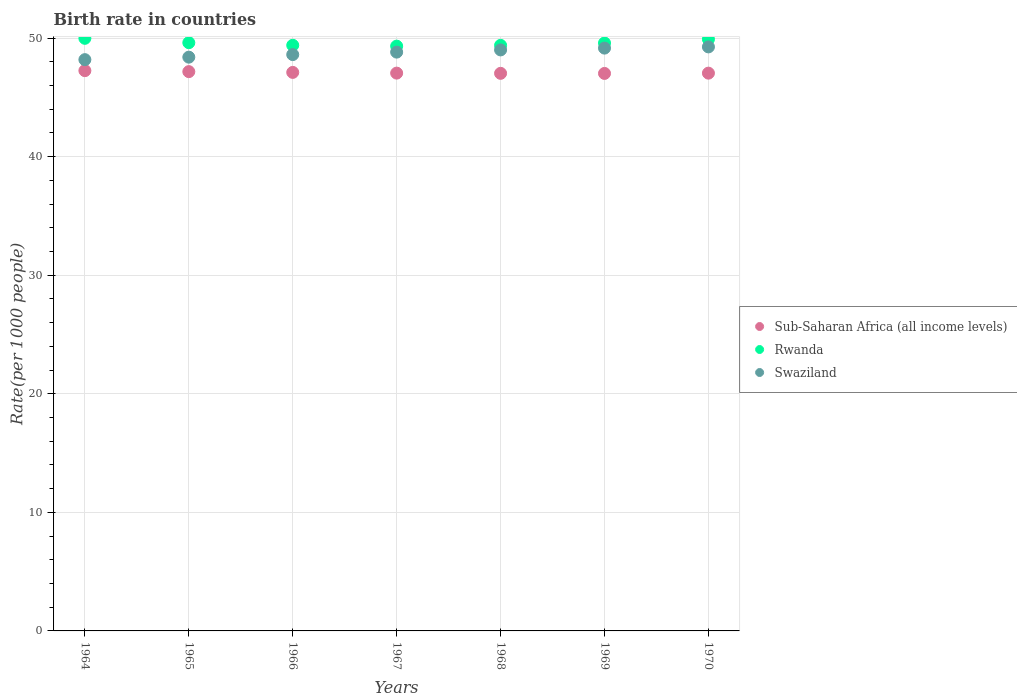Is the number of dotlines equal to the number of legend labels?
Your answer should be compact. Yes. What is the birth rate in Swaziland in 1966?
Offer a very short reply. 48.61. Across all years, what is the maximum birth rate in Sub-Saharan Africa (all income levels)?
Offer a very short reply. 47.26. Across all years, what is the minimum birth rate in Sub-Saharan Africa (all income levels)?
Provide a short and direct response. 47.02. In which year was the birth rate in Sub-Saharan Africa (all income levels) maximum?
Make the answer very short. 1964. In which year was the birth rate in Rwanda minimum?
Ensure brevity in your answer.  1967. What is the total birth rate in Sub-Saharan Africa (all income levels) in the graph?
Your answer should be compact. 329.7. What is the difference between the birth rate in Rwanda in 1968 and that in 1969?
Give a very brief answer. -0.2. What is the difference between the birth rate in Swaziland in 1964 and the birth rate in Rwanda in 1965?
Make the answer very short. -1.43. What is the average birth rate in Sub-Saharan Africa (all income levels) per year?
Your response must be concise. 47.1. In the year 1969, what is the difference between the birth rate in Rwanda and birth rate in Swaziland?
Offer a terse response. 0.43. What is the ratio of the birth rate in Rwanda in 1964 to that in 1967?
Make the answer very short. 1.01. What is the difference between the highest and the second highest birth rate in Sub-Saharan Africa (all income levels)?
Keep it short and to the point. 0.08. What is the difference between the highest and the lowest birth rate in Sub-Saharan Africa (all income levels)?
Give a very brief answer. 0.24. In how many years, is the birth rate in Sub-Saharan Africa (all income levels) greater than the average birth rate in Sub-Saharan Africa (all income levels) taken over all years?
Offer a terse response. 3. Is the sum of the birth rate in Sub-Saharan Africa (all income levels) in 1964 and 1965 greater than the maximum birth rate in Rwanda across all years?
Offer a very short reply. Yes. Does the birth rate in Sub-Saharan Africa (all income levels) monotonically increase over the years?
Ensure brevity in your answer.  No. Is the birth rate in Swaziland strictly less than the birth rate in Rwanda over the years?
Keep it short and to the point. Yes. How many dotlines are there?
Offer a very short reply. 3. What is the difference between two consecutive major ticks on the Y-axis?
Your response must be concise. 10. Does the graph contain any zero values?
Provide a succinct answer. No. Does the graph contain grids?
Keep it short and to the point. Yes. How many legend labels are there?
Offer a very short reply. 3. How are the legend labels stacked?
Provide a short and direct response. Vertical. What is the title of the graph?
Make the answer very short. Birth rate in countries. What is the label or title of the Y-axis?
Offer a very short reply. Rate(per 1000 people). What is the Rate(per 1000 people) in Sub-Saharan Africa (all income levels) in 1964?
Offer a terse response. 47.26. What is the Rate(per 1000 people) in Rwanda in 1964?
Your answer should be compact. 49.98. What is the Rate(per 1000 people) in Swaziland in 1964?
Give a very brief answer. 48.19. What is the Rate(per 1000 people) of Sub-Saharan Africa (all income levels) in 1965?
Provide a succinct answer. 47.18. What is the Rate(per 1000 people) of Rwanda in 1965?
Give a very brief answer. 49.62. What is the Rate(per 1000 people) in Swaziland in 1965?
Give a very brief answer. 48.4. What is the Rate(per 1000 people) in Sub-Saharan Africa (all income levels) in 1966?
Provide a short and direct response. 47.11. What is the Rate(per 1000 people) of Rwanda in 1966?
Give a very brief answer. 49.4. What is the Rate(per 1000 people) of Swaziland in 1966?
Your response must be concise. 48.61. What is the Rate(per 1000 people) in Sub-Saharan Africa (all income levels) in 1967?
Your answer should be compact. 47.05. What is the Rate(per 1000 people) in Rwanda in 1967?
Provide a short and direct response. 49.33. What is the Rate(per 1000 people) in Swaziland in 1967?
Your answer should be very brief. 48.82. What is the Rate(per 1000 people) in Sub-Saharan Africa (all income levels) in 1968?
Offer a terse response. 47.03. What is the Rate(per 1000 people) in Rwanda in 1968?
Your answer should be compact. 49.39. What is the Rate(per 1000 people) in Swaziland in 1968?
Provide a succinct answer. 49.01. What is the Rate(per 1000 people) of Sub-Saharan Africa (all income levels) in 1969?
Give a very brief answer. 47.02. What is the Rate(per 1000 people) in Rwanda in 1969?
Make the answer very short. 49.59. What is the Rate(per 1000 people) in Swaziland in 1969?
Provide a short and direct response. 49.16. What is the Rate(per 1000 people) of Sub-Saharan Africa (all income levels) in 1970?
Your answer should be compact. 47.05. What is the Rate(per 1000 people) of Rwanda in 1970?
Ensure brevity in your answer.  49.91. What is the Rate(per 1000 people) in Swaziland in 1970?
Provide a short and direct response. 49.26. Across all years, what is the maximum Rate(per 1000 people) in Sub-Saharan Africa (all income levels)?
Your response must be concise. 47.26. Across all years, what is the maximum Rate(per 1000 people) in Rwanda?
Offer a very short reply. 49.98. Across all years, what is the maximum Rate(per 1000 people) in Swaziland?
Make the answer very short. 49.26. Across all years, what is the minimum Rate(per 1000 people) of Sub-Saharan Africa (all income levels)?
Make the answer very short. 47.02. Across all years, what is the minimum Rate(per 1000 people) in Rwanda?
Give a very brief answer. 49.33. Across all years, what is the minimum Rate(per 1000 people) of Swaziland?
Offer a very short reply. 48.19. What is the total Rate(per 1000 people) of Sub-Saharan Africa (all income levels) in the graph?
Provide a succinct answer. 329.7. What is the total Rate(per 1000 people) in Rwanda in the graph?
Your answer should be very brief. 347.22. What is the total Rate(per 1000 people) in Swaziland in the graph?
Make the answer very short. 341.45. What is the difference between the Rate(per 1000 people) in Sub-Saharan Africa (all income levels) in 1964 and that in 1965?
Offer a very short reply. 0.08. What is the difference between the Rate(per 1000 people) of Rwanda in 1964 and that in 1965?
Provide a short and direct response. 0.37. What is the difference between the Rate(per 1000 people) in Swaziland in 1964 and that in 1965?
Your answer should be compact. -0.21. What is the difference between the Rate(per 1000 people) of Sub-Saharan Africa (all income levels) in 1964 and that in 1966?
Your answer should be compact. 0.15. What is the difference between the Rate(per 1000 people) in Rwanda in 1964 and that in 1966?
Offer a terse response. 0.59. What is the difference between the Rate(per 1000 people) in Swaziland in 1964 and that in 1966?
Offer a very short reply. -0.43. What is the difference between the Rate(per 1000 people) in Sub-Saharan Africa (all income levels) in 1964 and that in 1967?
Offer a terse response. 0.21. What is the difference between the Rate(per 1000 people) of Rwanda in 1964 and that in 1967?
Your answer should be very brief. 0.66. What is the difference between the Rate(per 1000 people) of Swaziland in 1964 and that in 1967?
Provide a succinct answer. -0.64. What is the difference between the Rate(per 1000 people) of Sub-Saharan Africa (all income levels) in 1964 and that in 1968?
Offer a very short reply. 0.23. What is the difference between the Rate(per 1000 people) in Rwanda in 1964 and that in 1968?
Your response must be concise. 0.59. What is the difference between the Rate(per 1000 people) of Swaziland in 1964 and that in 1968?
Your answer should be compact. -0.82. What is the difference between the Rate(per 1000 people) in Sub-Saharan Africa (all income levels) in 1964 and that in 1969?
Provide a short and direct response. 0.24. What is the difference between the Rate(per 1000 people) in Rwanda in 1964 and that in 1969?
Your answer should be very brief. 0.4. What is the difference between the Rate(per 1000 people) of Swaziland in 1964 and that in 1969?
Provide a succinct answer. -0.97. What is the difference between the Rate(per 1000 people) in Sub-Saharan Africa (all income levels) in 1964 and that in 1970?
Offer a very short reply. 0.21. What is the difference between the Rate(per 1000 people) in Rwanda in 1964 and that in 1970?
Offer a terse response. 0.07. What is the difference between the Rate(per 1000 people) of Swaziland in 1964 and that in 1970?
Your response must be concise. -1.07. What is the difference between the Rate(per 1000 people) of Sub-Saharan Africa (all income levels) in 1965 and that in 1966?
Your answer should be very brief. 0.07. What is the difference between the Rate(per 1000 people) in Rwanda in 1965 and that in 1966?
Offer a very short reply. 0.22. What is the difference between the Rate(per 1000 people) in Swaziland in 1965 and that in 1966?
Give a very brief answer. -0.22. What is the difference between the Rate(per 1000 people) in Sub-Saharan Africa (all income levels) in 1965 and that in 1967?
Provide a short and direct response. 0.13. What is the difference between the Rate(per 1000 people) of Rwanda in 1965 and that in 1967?
Provide a succinct answer. 0.29. What is the difference between the Rate(per 1000 people) in Swaziland in 1965 and that in 1967?
Offer a very short reply. -0.42. What is the difference between the Rate(per 1000 people) in Sub-Saharan Africa (all income levels) in 1965 and that in 1968?
Provide a succinct answer. 0.14. What is the difference between the Rate(per 1000 people) in Rwanda in 1965 and that in 1968?
Make the answer very short. 0.22. What is the difference between the Rate(per 1000 people) of Swaziland in 1965 and that in 1968?
Your answer should be compact. -0.61. What is the difference between the Rate(per 1000 people) in Sub-Saharan Africa (all income levels) in 1965 and that in 1969?
Provide a short and direct response. 0.15. What is the difference between the Rate(per 1000 people) of Rwanda in 1965 and that in 1969?
Provide a succinct answer. 0.03. What is the difference between the Rate(per 1000 people) in Swaziland in 1965 and that in 1969?
Ensure brevity in your answer.  -0.76. What is the difference between the Rate(per 1000 people) of Sub-Saharan Africa (all income levels) in 1965 and that in 1970?
Give a very brief answer. 0.13. What is the difference between the Rate(per 1000 people) in Rwanda in 1965 and that in 1970?
Your answer should be compact. -0.29. What is the difference between the Rate(per 1000 people) of Swaziland in 1965 and that in 1970?
Make the answer very short. -0.86. What is the difference between the Rate(per 1000 people) in Sub-Saharan Africa (all income levels) in 1966 and that in 1967?
Ensure brevity in your answer.  0.06. What is the difference between the Rate(per 1000 people) in Rwanda in 1966 and that in 1967?
Make the answer very short. 0.07. What is the difference between the Rate(per 1000 people) in Swaziland in 1966 and that in 1967?
Your response must be concise. -0.21. What is the difference between the Rate(per 1000 people) in Sub-Saharan Africa (all income levels) in 1966 and that in 1968?
Your response must be concise. 0.08. What is the difference between the Rate(per 1000 people) in Rwanda in 1966 and that in 1968?
Offer a very short reply. 0.01. What is the difference between the Rate(per 1000 people) in Swaziland in 1966 and that in 1968?
Provide a short and direct response. -0.4. What is the difference between the Rate(per 1000 people) of Sub-Saharan Africa (all income levels) in 1966 and that in 1969?
Keep it short and to the point. 0.09. What is the difference between the Rate(per 1000 people) in Rwanda in 1966 and that in 1969?
Offer a terse response. -0.19. What is the difference between the Rate(per 1000 people) of Swaziland in 1966 and that in 1969?
Provide a succinct answer. -0.55. What is the difference between the Rate(per 1000 people) of Sub-Saharan Africa (all income levels) in 1966 and that in 1970?
Offer a very short reply. 0.06. What is the difference between the Rate(per 1000 people) in Rwanda in 1966 and that in 1970?
Your answer should be compact. -0.51. What is the difference between the Rate(per 1000 people) in Swaziland in 1966 and that in 1970?
Keep it short and to the point. -0.65. What is the difference between the Rate(per 1000 people) of Sub-Saharan Africa (all income levels) in 1967 and that in 1968?
Your answer should be compact. 0.02. What is the difference between the Rate(per 1000 people) in Rwanda in 1967 and that in 1968?
Make the answer very short. -0.07. What is the difference between the Rate(per 1000 people) in Swaziland in 1967 and that in 1968?
Your answer should be very brief. -0.19. What is the difference between the Rate(per 1000 people) of Sub-Saharan Africa (all income levels) in 1967 and that in 1969?
Give a very brief answer. 0.03. What is the difference between the Rate(per 1000 people) in Rwanda in 1967 and that in 1969?
Keep it short and to the point. -0.26. What is the difference between the Rate(per 1000 people) of Swaziland in 1967 and that in 1969?
Your answer should be compact. -0.34. What is the difference between the Rate(per 1000 people) in Sub-Saharan Africa (all income levels) in 1967 and that in 1970?
Your response must be concise. 0. What is the difference between the Rate(per 1000 people) in Rwanda in 1967 and that in 1970?
Your answer should be very brief. -0.58. What is the difference between the Rate(per 1000 people) of Swaziland in 1967 and that in 1970?
Your answer should be compact. -0.44. What is the difference between the Rate(per 1000 people) of Sub-Saharan Africa (all income levels) in 1968 and that in 1969?
Offer a terse response. 0.01. What is the difference between the Rate(per 1000 people) of Rwanda in 1968 and that in 1969?
Your answer should be compact. -0.2. What is the difference between the Rate(per 1000 people) of Swaziland in 1968 and that in 1969?
Your answer should be compact. -0.15. What is the difference between the Rate(per 1000 people) of Sub-Saharan Africa (all income levels) in 1968 and that in 1970?
Your answer should be compact. -0.02. What is the difference between the Rate(per 1000 people) of Rwanda in 1968 and that in 1970?
Offer a terse response. -0.52. What is the difference between the Rate(per 1000 people) in Swaziland in 1968 and that in 1970?
Give a very brief answer. -0.25. What is the difference between the Rate(per 1000 people) in Sub-Saharan Africa (all income levels) in 1969 and that in 1970?
Provide a short and direct response. -0.02. What is the difference between the Rate(per 1000 people) in Rwanda in 1969 and that in 1970?
Provide a short and direct response. -0.32. What is the difference between the Rate(per 1000 people) in Swaziland in 1969 and that in 1970?
Provide a succinct answer. -0.1. What is the difference between the Rate(per 1000 people) of Sub-Saharan Africa (all income levels) in 1964 and the Rate(per 1000 people) of Rwanda in 1965?
Your answer should be very brief. -2.36. What is the difference between the Rate(per 1000 people) of Sub-Saharan Africa (all income levels) in 1964 and the Rate(per 1000 people) of Swaziland in 1965?
Offer a terse response. -1.14. What is the difference between the Rate(per 1000 people) in Rwanda in 1964 and the Rate(per 1000 people) in Swaziland in 1965?
Give a very brief answer. 1.59. What is the difference between the Rate(per 1000 people) of Sub-Saharan Africa (all income levels) in 1964 and the Rate(per 1000 people) of Rwanda in 1966?
Your response must be concise. -2.14. What is the difference between the Rate(per 1000 people) of Sub-Saharan Africa (all income levels) in 1964 and the Rate(per 1000 people) of Swaziland in 1966?
Provide a short and direct response. -1.35. What is the difference between the Rate(per 1000 people) of Rwanda in 1964 and the Rate(per 1000 people) of Swaziland in 1966?
Ensure brevity in your answer.  1.37. What is the difference between the Rate(per 1000 people) of Sub-Saharan Africa (all income levels) in 1964 and the Rate(per 1000 people) of Rwanda in 1967?
Your response must be concise. -2.07. What is the difference between the Rate(per 1000 people) in Sub-Saharan Africa (all income levels) in 1964 and the Rate(per 1000 people) in Swaziland in 1967?
Ensure brevity in your answer.  -1.56. What is the difference between the Rate(per 1000 people) of Rwanda in 1964 and the Rate(per 1000 people) of Swaziland in 1967?
Make the answer very short. 1.16. What is the difference between the Rate(per 1000 people) of Sub-Saharan Africa (all income levels) in 1964 and the Rate(per 1000 people) of Rwanda in 1968?
Keep it short and to the point. -2.13. What is the difference between the Rate(per 1000 people) of Sub-Saharan Africa (all income levels) in 1964 and the Rate(per 1000 people) of Swaziland in 1968?
Provide a succinct answer. -1.75. What is the difference between the Rate(per 1000 people) of Sub-Saharan Africa (all income levels) in 1964 and the Rate(per 1000 people) of Rwanda in 1969?
Ensure brevity in your answer.  -2.33. What is the difference between the Rate(per 1000 people) of Sub-Saharan Africa (all income levels) in 1964 and the Rate(per 1000 people) of Swaziland in 1969?
Your answer should be compact. -1.9. What is the difference between the Rate(per 1000 people) of Rwanda in 1964 and the Rate(per 1000 people) of Swaziland in 1969?
Provide a succinct answer. 0.82. What is the difference between the Rate(per 1000 people) of Sub-Saharan Africa (all income levels) in 1964 and the Rate(per 1000 people) of Rwanda in 1970?
Your response must be concise. -2.65. What is the difference between the Rate(per 1000 people) in Sub-Saharan Africa (all income levels) in 1964 and the Rate(per 1000 people) in Swaziland in 1970?
Your answer should be very brief. -2. What is the difference between the Rate(per 1000 people) in Rwanda in 1964 and the Rate(per 1000 people) in Swaziland in 1970?
Ensure brevity in your answer.  0.72. What is the difference between the Rate(per 1000 people) of Sub-Saharan Africa (all income levels) in 1965 and the Rate(per 1000 people) of Rwanda in 1966?
Make the answer very short. -2.22. What is the difference between the Rate(per 1000 people) in Sub-Saharan Africa (all income levels) in 1965 and the Rate(per 1000 people) in Swaziland in 1966?
Your answer should be very brief. -1.44. What is the difference between the Rate(per 1000 people) of Sub-Saharan Africa (all income levels) in 1965 and the Rate(per 1000 people) of Rwanda in 1967?
Your answer should be compact. -2.15. What is the difference between the Rate(per 1000 people) in Sub-Saharan Africa (all income levels) in 1965 and the Rate(per 1000 people) in Swaziland in 1967?
Offer a very short reply. -1.65. What is the difference between the Rate(per 1000 people) in Rwanda in 1965 and the Rate(per 1000 people) in Swaziland in 1967?
Your answer should be compact. 0.8. What is the difference between the Rate(per 1000 people) of Sub-Saharan Africa (all income levels) in 1965 and the Rate(per 1000 people) of Rwanda in 1968?
Give a very brief answer. -2.22. What is the difference between the Rate(per 1000 people) in Sub-Saharan Africa (all income levels) in 1965 and the Rate(per 1000 people) in Swaziland in 1968?
Make the answer very short. -1.83. What is the difference between the Rate(per 1000 people) in Rwanda in 1965 and the Rate(per 1000 people) in Swaziland in 1968?
Keep it short and to the point. 0.61. What is the difference between the Rate(per 1000 people) of Sub-Saharan Africa (all income levels) in 1965 and the Rate(per 1000 people) of Rwanda in 1969?
Keep it short and to the point. -2.41. What is the difference between the Rate(per 1000 people) in Sub-Saharan Africa (all income levels) in 1965 and the Rate(per 1000 people) in Swaziland in 1969?
Provide a short and direct response. -1.98. What is the difference between the Rate(per 1000 people) of Rwanda in 1965 and the Rate(per 1000 people) of Swaziland in 1969?
Your answer should be very brief. 0.46. What is the difference between the Rate(per 1000 people) in Sub-Saharan Africa (all income levels) in 1965 and the Rate(per 1000 people) in Rwanda in 1970?
Give a very brief answer. -2.73. What is the difference between the Rate(per 1000 people) of Sub-Saharan Africa (all income levels) in 1965 and the Rate(per 1000 people) of Swaziland in 1970?
Your response must be concise. -2.09. What is the difference between the Rate(per 1000 people) of Rwanda in 1965 and the Rate(per 1000 people) of Swaziland in 1970?
Provide a short and direct response. 0.35. What is the difference between the Rate(per 1000 people) of Sub-Saharan Africa (all income levels) in 1966 and the Rate(per 1000 people) of Rwanda in 1967?
Your response must be concise. -2.22. What is the difference between the Rate(per 1000 people) of Sub-Saharan Africa (all income levels) in 1966 and the Rate(per 1000 people) of Swaziland in 1967?
Your answer should be very brief. -1.71. What is the difference between the Rate(per 1000 people) in Rwanda in 1966 and the Rate(per 1000 people) in Swaziland in 1967?
Make the answer very short. 0.58. What is the difference between the Rate(per 1000 people) of Sub-Saharan Africa (all income levels) in 1966 and the Rate(per 1000 people) of Rwanda in 1968?
Offer a terse response. -2.28. What is the difference between the Rate(per 1000 people) in Sub-Saharan Africa (all income levels) in 1966 and the Rate(per 1000 people) in Swaziland in 1968?
Provide a succinct answer. -1.9. What is the difference between the Rate(per 1000 people) in Rwanda in 1966 and the Rate(per 1000 people) in Swaziland in 1968?
Ensure brevity in your answer.  0.39. What is the difference between the Rate(per 1000 people) in Sub-Saharan Africa (all income levels) in 1966 and the Rate(per 1000 people) in Rwanda in 1969?
Your answer should be very brief. -2.48. What is the difference between the Rate(per 1000 people) of Sub-Saharan Africa (all income levels) in 1966 and the Rate(per 1000 people) of Swaziland in 1969?
Provide a succinct answer. -2.05. What is the difference between the Rate(per 1000 people) of Rwanda in 1966 and the Rate(per 1000 people) of Swaziland in 1969?
Make the answer very short. 0.24. What is the difference between the Rate(per 1000 people) of Sub-Saharan Africa (all income levels) in 1966 and the Rate(per 1000 people) of Rwanda in 1970?
Keep it short and to the point. -2.8. What is the difference between the Rate(per 1000 people) in Sub-Saharan Africa (all income levels) in 1966 and the Rate(per 1000 people) in Swaziland in 1970?
Offer a terse response. -2.15. What is the difference between the Rate(per 1000 people) of Rwanda in 1966 and the Rate(per 1000 people) of Swaziland in 1970?
Make the answer very short. 0.14. What is the difference between the Rate(per 1000 people) of Sub-Saharan Africa (all income levels) in 1967 and the Rate(per 1000 people) of Rwanda in 1968?
Your answer should be compact. -2.34. What is the difference between the Rate(per 1000 people) in Sub-Saharan Africa (all income levels) in 1967 and the Rate(per 1000 people) in Swaziland in 1968?
Your answer should be compact. -1.96. What is the difference between the Rate(per 1000 people) of Rwanda in 1967 and the Rate(per 1000 people) of Swaziland in 1968?
Your response must be concise. 0.32. What is the difference between the Rate(per 1000 people) of Sub-Saharan Africa (all income levels) in 1967 and the Rate(per 1000 people) of Rwanda in 1969?
Your answer should be compact. -2.54. What is the difference between the Rate(per 1000 people) of Sub-Saharan Africa (all income levels) in 1967 and the Rate(per 1000 people) of Swaziland in 1969?
Provide a short and direct response. -2.11. What is the difference between the Rate(per 1000 people) of Rwanda in 1967 and the Rate(per 1000 people) of Swaziland in 1969?
Your answer should be compact. 0.17. What is the difference between the Rate(per 1000 people) in Sub-Saharan Africa (all income levels) in 1967 and the Rate(per 1000 people) in Rwanda in 1970?
Offer a terse response. -2.86. What is the difference between the Rate(per 1000 people) of Sub-Saharan Africa (all income levels) in 1967 and the Rate(per 1000 people) of Swaziland in 1970?
Make the answer very short. -2.21. What is the difference between the Rate(per 1000 people) of Rwanda in 1967 and the Rate(per 1000 people) of Swaziland in 1970?
Your response must be concise. 0.07. What is the difference between the Rate(per 1000 people) in Sub-Saharan Africa (all income levels) in 1968 and the Rate(per 1000 people) in Rwanda in 1969?
Provide a short and direct response. -2.56. What is the difference between the Rate(per 1000 people) in Sub-Saharan Africa (all income levels) in 1968 and the Rate(per 1000 people) in Swaziland in 1969?
Your answer should be compact. -2.13. What is the difference between the Rate(per 1000 people) in Rwanda in 1968 and the Rate(per 1000 people) in Swaziland in 1969?
Offer a very short reply. 0.23. What is the difference between the Rate(per 1000 people) of Sub-Saharan Africa (all income levels) in 1968 and the Rate(per 1000 people) of Rwanda in 1970?
Offer a terse response. -2.88. What is the difference between the Rate(per 1000 people) of Sub-Saharan Africa (all income levels) in 1968 and the Rate(per 1000 people) of Swaziland in 1970?
Offer a terse response. -2.23. What is the difference between the Rate(per 1000 people) of Rwanda in 1968 and the Rate(per 1000 people) of Swaziland in 1970?
Offer a terse response. 0.13. What is the difference between the Rate(per 1000 people) in Sub-Saharan Africa (all income levels) in 1969 and the Rate(per 1000 people) in Rwanda in 1970?
Your answer should be compact. -2.89. What is the difference between the Rate(per 1000 people) of Sub-Saharan Africa (all income levels) in 1969 and the Rate(per 1000 people) of Swaziland in 1970?
Your answer should be very brief. -2.24. What is the difference between the Rate(per 1000 people) of Rwanda in 1969 and the Rate(per 1000 people) of Swaziland in 1970?
Offer a terse response. 0.33. What is the average Rate(per 1000 people) of Sub-Saharan Africa (all income levels) per year?
Your response must be concise. 47.1. What is the average Rate(per 1000 people) in Rwanda per year?
Give a very brief answer. 49.6. What is the average Rate(per 1000 people) of Swaziland per year?
Ensure brevity in your answer.  48.78. In the year 1964, what is the difference between the Rate(per 1000 people) in Sub-Saharan Africa (all income levels) and Rate(per 1000 people) in Rwanda?
Offer a terse response. -2.73. In the year 1964, what is the difference between the Rate(per 1000 people) of Sub-Saharan Africa (all income levels) and Rate(per 1000 people) of Swaziland?
Your answer should be compact. -0.93. In the year 1964, what is the difference between the Rate(per 1000 people) in Rwanda and Rate(per 1000 people) in Swaziland?
Your answer should be very brief. 1.8. In the year 1965, what is the difference between the Rate(per 1000 people) in Sub-Saharan Africa (all income levels) and Rate(per 1000 people) in Rwanda?
Provide a succinct answer. -2.44. In the year 1965, what is the difference between the Rate(per 1000 people) in Sub-Saharan Africa (all income levels) and Rate(per 1000 people) in Swaziland?
Make the answer very short. -1.22. In the year 1965, what is the difference between the Rate(per 1000 people) of Rwanda and Rate(per 1000 people) of Swaziland?
Give a very brief answer. 1.22. In the year 1966, what is the difference between the Rate(per 1000 people) in Sub-Saharan Africa (all income levels) and Rate(per 1000 people) in Rwanda?
Your answer should be very brief. -2.29. In the year 1966, what is the difference between the Rate(per 1000 people) of Sub-Saharan Africa (all income levels) and Rate(per 1000 people) of Swaziland?
Keep it short and to the point. -1.5. In the year 1966, what is the difference between the Rate(per 1000 people) of Rwanda and Rate(per 1000 people) of Swaziland?
Offer a terse response. 0.79. In the year 1967, what is the difference between the Rate(per 1000 people) in Sub-Saharan Africa (all income levels) and Rate(per 1000 people) in Rwanda?
Give a very brief answer. -2.28. In the year 1967, what is the difference between the Rate(per 1000 people) of Sub-Saharan Africa (all income levels) and Rate(per 1000 people) of Swaziland?
Your answer should be compact. -1.77. In the year 1967, what is the difference between the Rate(per 1000 people) in Rwanda and Rate(per 1000 people) in Swaziland?
Ensure brevity in your answer.  0.51. In the year 1968, what is the difference between the Rate(per 1000 people) of Sub-Saharan Africa (all income levels) and Rate(per 1000 people) of Rwanda?
Offer a very short reply. -2.36. In the year 1968, what is the difference between the Rate(per 1000 people) in Sub-Saharan Africa (all income levels) and Rate(per 1000 people) in Swaziland?
Ensure brevity in your answer.  -1.98. In the year 1968, what is the difference between the Rate(per 1000 people) in Rwanda and Rate(per 1000 people) in Swaziland?
Your response must be concise. 0.39. In the year 1969, what is the difference between the Rate(per 1000 people) of Sub-Saharan Africa (all income levels) and Rate(per 1000 people) of Rwanda?
Your answer should be very brief. -2.57. In the year 1969, what is the difference between the Rate(per 1000 people) in Sub-Saharan Africa (all income levels) and Rate(per 1000 people) in Swaziland?
Offer a terse response. -2.14. In the year 1969, what is the difference between the Rate(per 1000 people) in Rwanda and Rate(per 1000 people) in Swaziland?
Give a very brief answer. 0.43. In the year 1970, what is the difference between the Rate(per 1000 people) of Sub-Saharan Africa (all income levels) and Rate(per 1000 people) of Rwanda?
Give a very brief answer. -2.86. In the year 1970, what is the difference between the Rate(per 1000 people) in Sub-Saharan Africa (all income levels) and Rate(per 1000 people) in Swaziland?
Make the answer very short. -2.21. In the year 1970, what is the difference between the Rate(per 1000 people) of Rwanda and Rate(per 1000 people) of Swaziland?
Provide a short and direct response. 0.65. What is the ratio of the Rate(per 1000 people) in Rwanda in 1964 to that in 1965?
Provide a short and direct response. 1.01. What is the ratio of the Rate(per 1000 people) of Sub-Saharan Africa (all income levels) in 1964 to that in 1966?
Offer a terse response. 1. What is the ratio of the Rate(per 1000 people) in Rwanda in 1964 to that in 1966?
Make the answer very short. 1.01. What is the ratio of the Rate(per 1000 people) in Rwanda in 1964 to that in 1967?
Provide a succinct answer. 1.01. What is the ratio of the Rate(per 1000 people) in Swaziland in 1964 to that in 1967?
Provide a succinct answer. 0.99. What is the ratio of the Rate(per 1000 people) in Sub-Saharan Africa (all income levels) in 1964 to that in 1968?
Provide a short and direct response. 1. What is the ratio of the Rate(per 1000 people) in Swaziland in 1964 to that in 1968?
Offer a very short reply. 0.98. What is the ratio of the Rate(per 1000 people) of Sub-Saharan Africa (all income levels) in 1964 to that in 1969?
Keep it short and to the point. 1. What is the ratio of the Rate(per 1000 people) of Rwanda in 1964 to that in 1969?
Make the answer very short. 1.01. What is the ratio of the Rate(per 1000 people) of Swaziland in 1964 to that in 1969?
Offer a terse response. 0.98. What is the ratio of the Rate(per 1000 people) of Rwanda in 1964 to that in 1970?
Provide a short and direct response. 1. What is the ratio of the Rate(per 1000 people) of Swaziland in 1964 to that in 1970?
Ensure brevity in your answer.  0.98. What is the ratio of the Rate(per 1000 people) of Sub-Saharan Africa (all income levels) in 1965 to that in 1966?
Offer a terse response. 1. What is the ratio of the Rate(per 1000 people) in Sub-Saharan Africa (all income levels) in 1965 to that in 1967?
Keep it short and to the point. 1. What is the ratio of the Rate(per 1000 people) in Rwanda in 1965 to that in 1967?
Make the answer very short. 1.01. What is the ratio of the Rate(per 1000 people) in Swaziland in 1965 to that in 1968?
Provide a succinct answer. 0.99. What is the ratio of the Rate(per 1000 people) in Swaziland in 1965 to that in 1969?
Your answer should be very brief. 0.98. What is the ratio of the Rate(per 1000 people) in Sub-Saharan Africa (all income levels) in 1965 to that in 1970?
Ensure brevity in your answer.  1. What is the ratio of the Rate(per 1000 people) in Rwanda in 1965 to that in 1970?
Offer a terse response. 0.99. What is the ratio of the Rate(per 1000 people) in Swaziland in 1965 to that in 1970?
Ensure brevity in your answer.  0.98. What is the ratio of the Rate(per 1000 people) of Sub-Saharan Africa (all income levels) in 1966 to that in 1967?
Offer a terse response. 1. What is the ratio of the Rate(per 1000 people) of Rwanda in 1966 to that in 1968?
Your response must be concise. 1. What is the ratio of the Rate(per 1000 people) of Swaziland in 1966 to that in 1968?
Provide a short and direct response. 0.99. What is the ratio of the Rate(per 1000 people) in Rwanda in 1966 to that in 1969?
Your answer should be very brief. 1. What is the ratio of the Rate(per 1000 people) of Swaziland in 1966 to that in 1969?
Provide a succinct answer. 0.99. What is the ratio of the Rate(per 1000 people) of Rwanda in 1966 to that in 1970?
Give a very brief answer. 0.99. What is the ratio of the Rate(per 1000 people) in Sub-Saharan Africa (all income levels) in 1967 to that in 1969?
Your answer should be compact. 1. What is the ratio of the Rate(per 1000 people) of Swaziland in 1967 to that in 1969?
Your answer should be compact. 0.99. What is the ratio of the Rate(per 1000 people) in Sub-Saharan Africa (all income levels) in 1967 to that in 1970?
Your answer should be very brief. 1. What is the ratio of the Rate(per 1000 people) of Rwanda in 1967 to that in 1970?
Keep it short and to the point. 0.99. What is the ratio of the Rate(per 1000 people) in Sub-Saharan Africa (all income levels) in 1968 to that in 1969?
Provide a succinct answer. 1. What is the ratio of the Rate(per 1000 people) in Rwanda in 1968 to that in 1969?
Make the answer very short. 1. What is the ratio of the Rate(per 1000 people) in Sub-Saharan Africa (all income levels) in 1968 to that in 1970?
Your response must be concise. 1. What is the ratio of the Rate(per 1000 people) in Sub-Saharan Africa (all income levels) in 1969 to that in 1970?
Offer a very short reply. 1. What is the difference between the highest and the second highest Rate(per 1000 people) of Sub-Saharan Africa (all income levels)?
Your answer should be very brief. 0.08. What is the difference between the highest and the second highest Rate(per 1000 people) of Rwanda?
Give a very brief answer. 0.07. What is the difference between the highest and the second highest Rate(per 1000 people) in Swaziland?
Make the answer very short. 0.1. What is the difference between the highest and the lowest Rate(per 1000 people) in Sub-Saharan Africa (all income levels)?
Your answer should be very brief. 0.24. What is the difference between the highest and the lowest Rate(per 1000 people) in Rwanda?
Your answer should be compact. 0.66. What is the difference between the highest and the lowest Rate(per 1000 people) of Swaziland?
Ensure brevity in your answer.  1.07. 